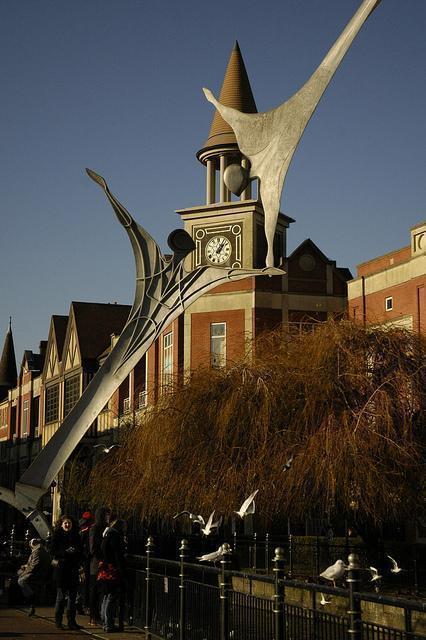The human-shaped decorations are made of what material?
From the following four choices, select the correct answer to address the question.
Options: Metal, wood, cement, plastic. Metal. 